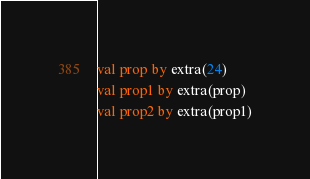<code> <loc_0><loc_0><loc_500><loc_500><_Kotlin_>val prop by extra(24)
val prop1 by extra(prop)
val prop2 by extra(prop1)
</code> 